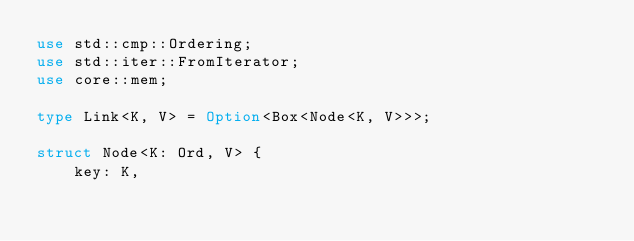Convert code to text. <code><loc_0><loc_0><loc_500><loc_500><_Rust_>use std::cmp::Ordering;
use std::iter::FromIterator;
use core::mem;

type Link<K, V> = Option<Box<Node<K, V>>>;

struct Node<K: Ord, V> {
    key: K,</code> 